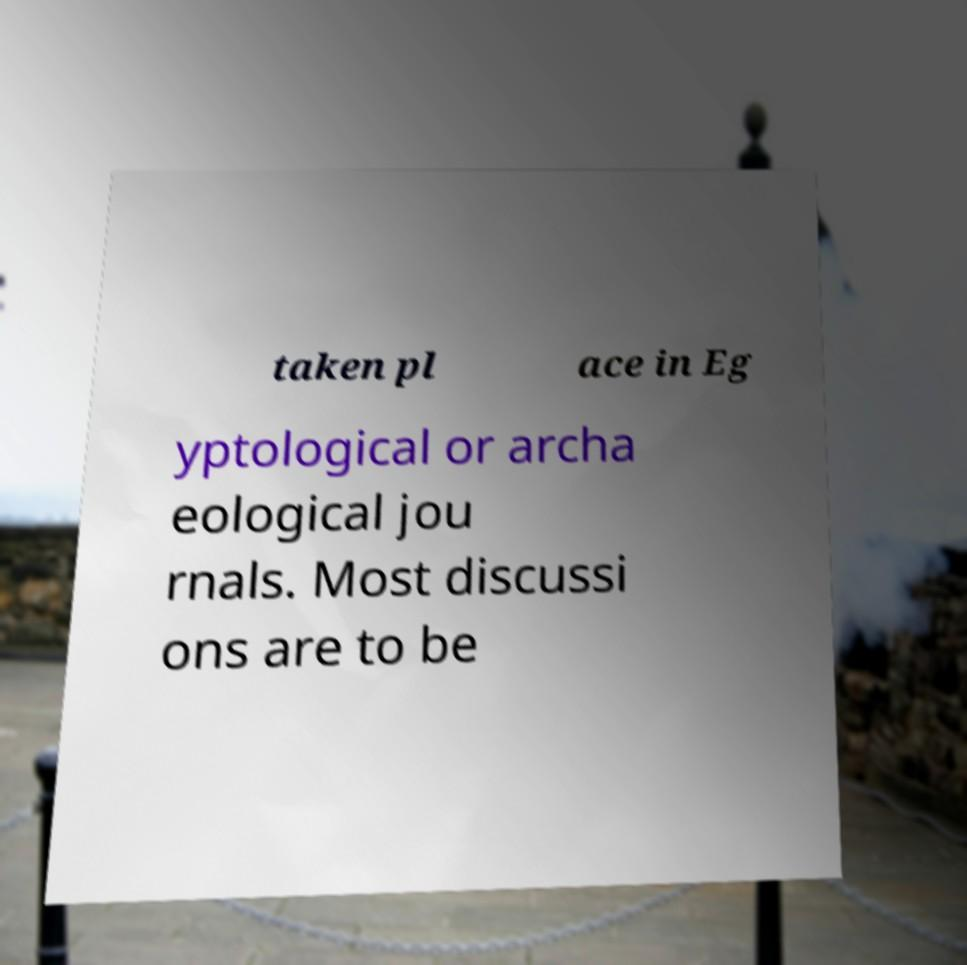What messages or text are displayed in this image? I need them in a readable, typed format. taken pl ace in Eg yptological or archa eological jou rnals. Most discussi ons are to be 